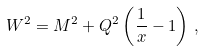<formula> <loc_0><loc_0><loc_500><loc_500>W ^ { 2 } = M ^ { 2 } + Q ^ { 2 } \left ( \frac { 1 } { x } - 1 \right ) \, ,</formula> 